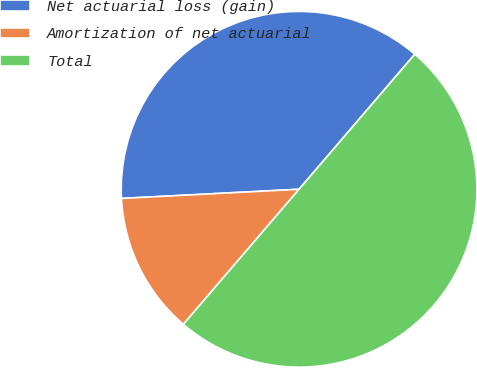Convert chart to OTSL. <chart><loc_0><loc_0><loc_500><loc_500><pie_chart><fcel>Net actuarial loss (gain)<fcel>Amortization of net actuarial<fcel>Total<nl><fcel>37.1%<fcel>12.9%<fcel>50.0%<nl></chart> 